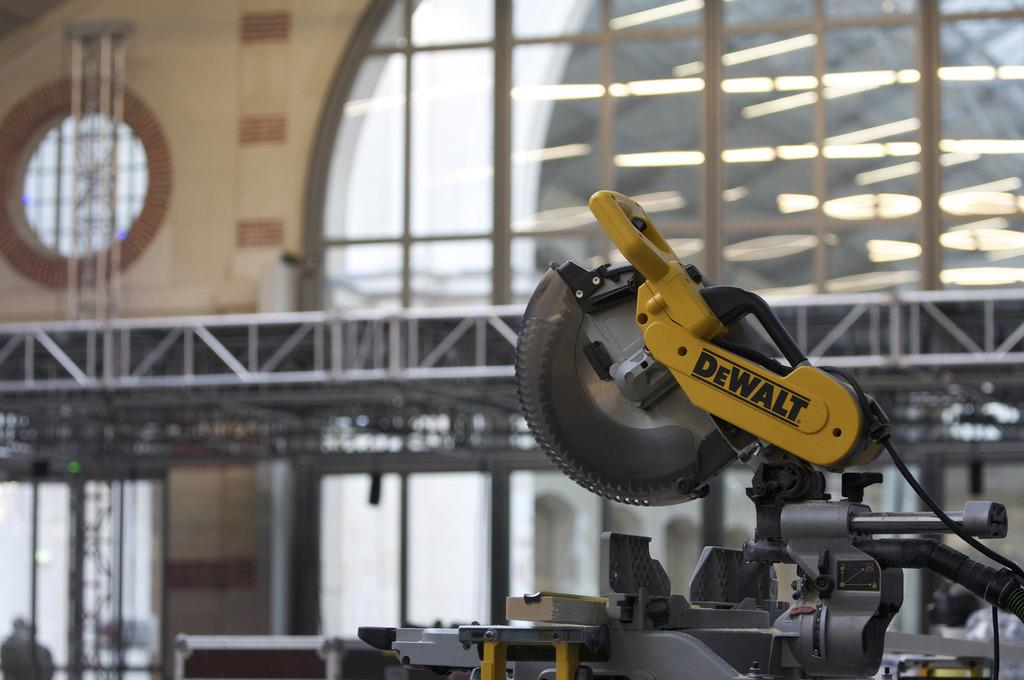<image>
Present a compact description of the photo's key features. A Dewalt saw sits on a table with a clock in the distance. 